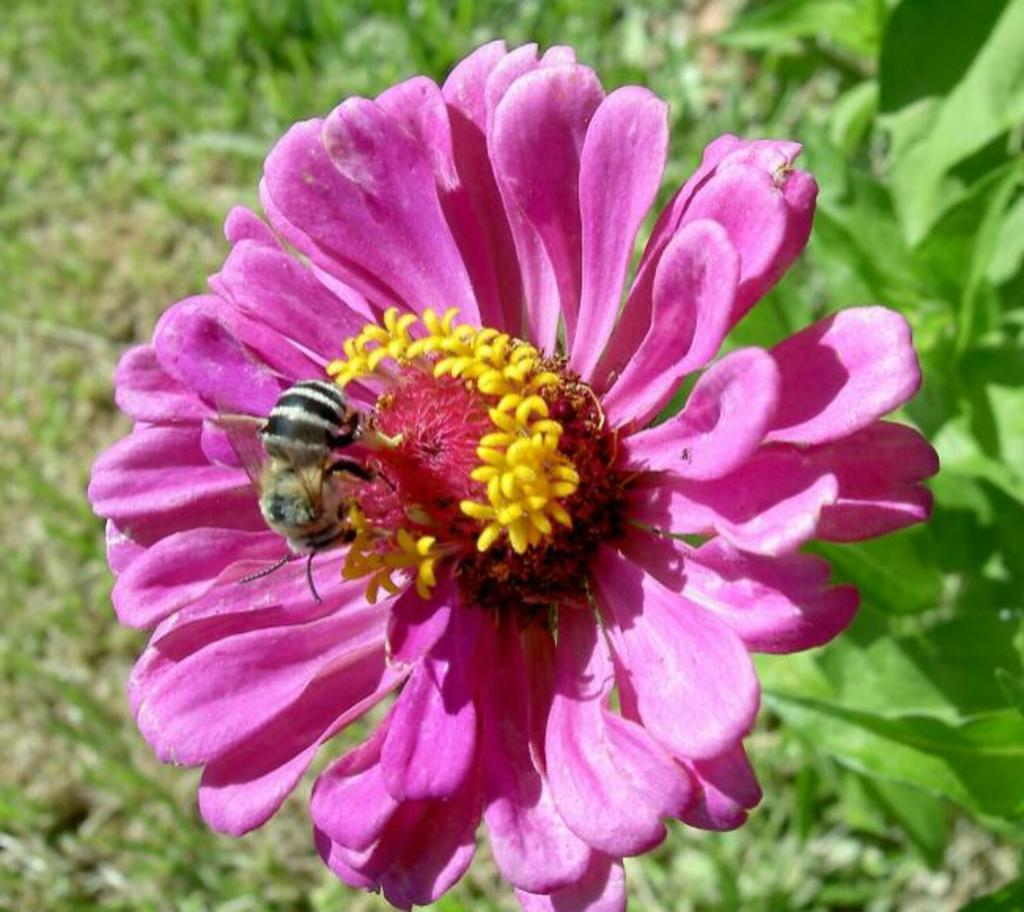What type of flower is in the image? There is a pink flower in the image. Is there any other living organism interacting with the flower? Yes, there is a honey bee on the flower. What color is the background of the flower? The background of the flower is blue. What type of disease can be seen affecting the flower in the image? There is no disease affecting the flower in the image; it appears healthy. What division of mathematics is being used to solve a problem in the image? There is no mathematical problem or division present in the image. 